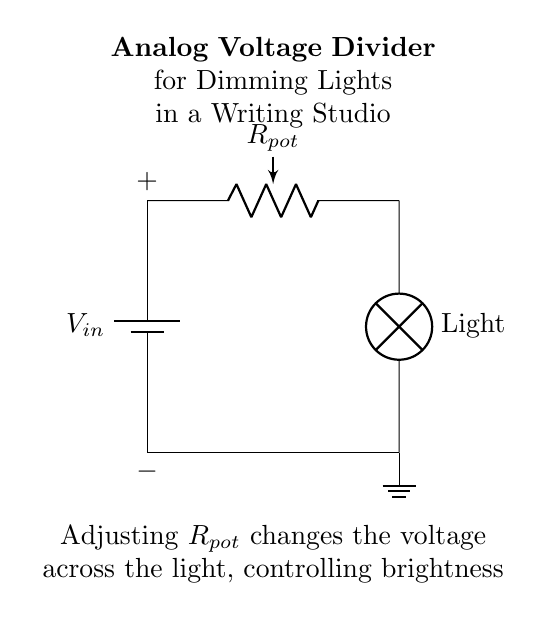What is the name of the variable resistor in the circuit? The variable resistor in the circuit is labeled as the potentiometer, commonly known as a pot.
Answer: potentiometer What is the purpose of the potentiometer in this circuit? The potentiometer adjusts the resistance, which in turn affects the voltage across the light bulb, allowing for control of brightness.
Answer: dimming What component is used to represent the light source? The circuit shows a lamp to represent the light source that will be dimmed by the voltage adjustment.
Answer: lamp How many terminals does the battery have? The battery in the circuit has two terminals: a positive and a negative terminal, which provide the voltage for the circuit.
Answer: two What happens when the resistance of the potentiometer is increased? Increasing the resistance of the potentiometer leads to a decrease in the voltage across the light bulb, resulting in dimmer light.
Answer: dimmer light What voltage is indicated at the entrance of the circuit? The voltage at the entrance is denoted as Vin, which is the supplied voltage from the battery.
Answer: Vin In which direction does the current flow through the circuit? The current flows from the positive terminal of the battery, through the potentiometer and the lamp, and returns to the negative terminal of the battery.
Answer: clockwise 